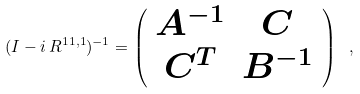<formula> <loc_0><loc_0><loc_500><loc_500>( I - i \, R ^ { 1 1 , 1 } ) ^ { - 1 } = \left ( \begin{array} { c c } A ^ { - 1 } & C \\ C ^ { T } & B ^ { - 1 } \\ \end{array} \right ) \ ,</formula> 